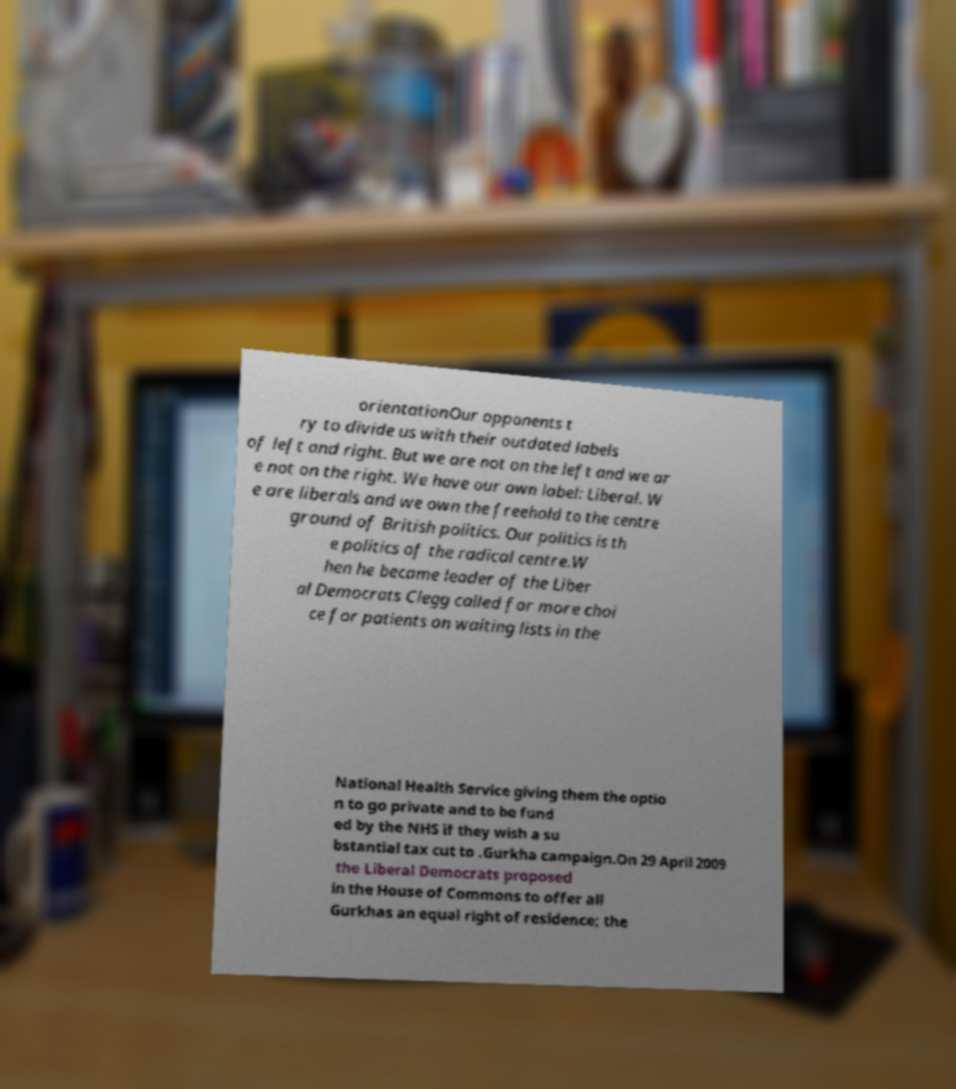Could you assist in decoding the text presented in this image and type it out clearly? orientationOur opponents t ry to divide us with their outdated labels of left and right. But we are not on the left and we ar e not on the right. We have our own label: Liberal. W e are liberals and we own the freehold to the centre ground of British politics. Our politics is th e politics of the radical centre.W hen he became leader of the Liber al Democrats Clegg called for more choi ce for patients on waiting lists in the National Health Service giving them the optio n to go private and to be fund ed by the NHS if they wish a su bstantial tax cut to .Gurkha campaign.On 29 April 2009 the Liberal Democrats proposed in the House of Commons to offer all Gurkhas an equal right of residence; the 